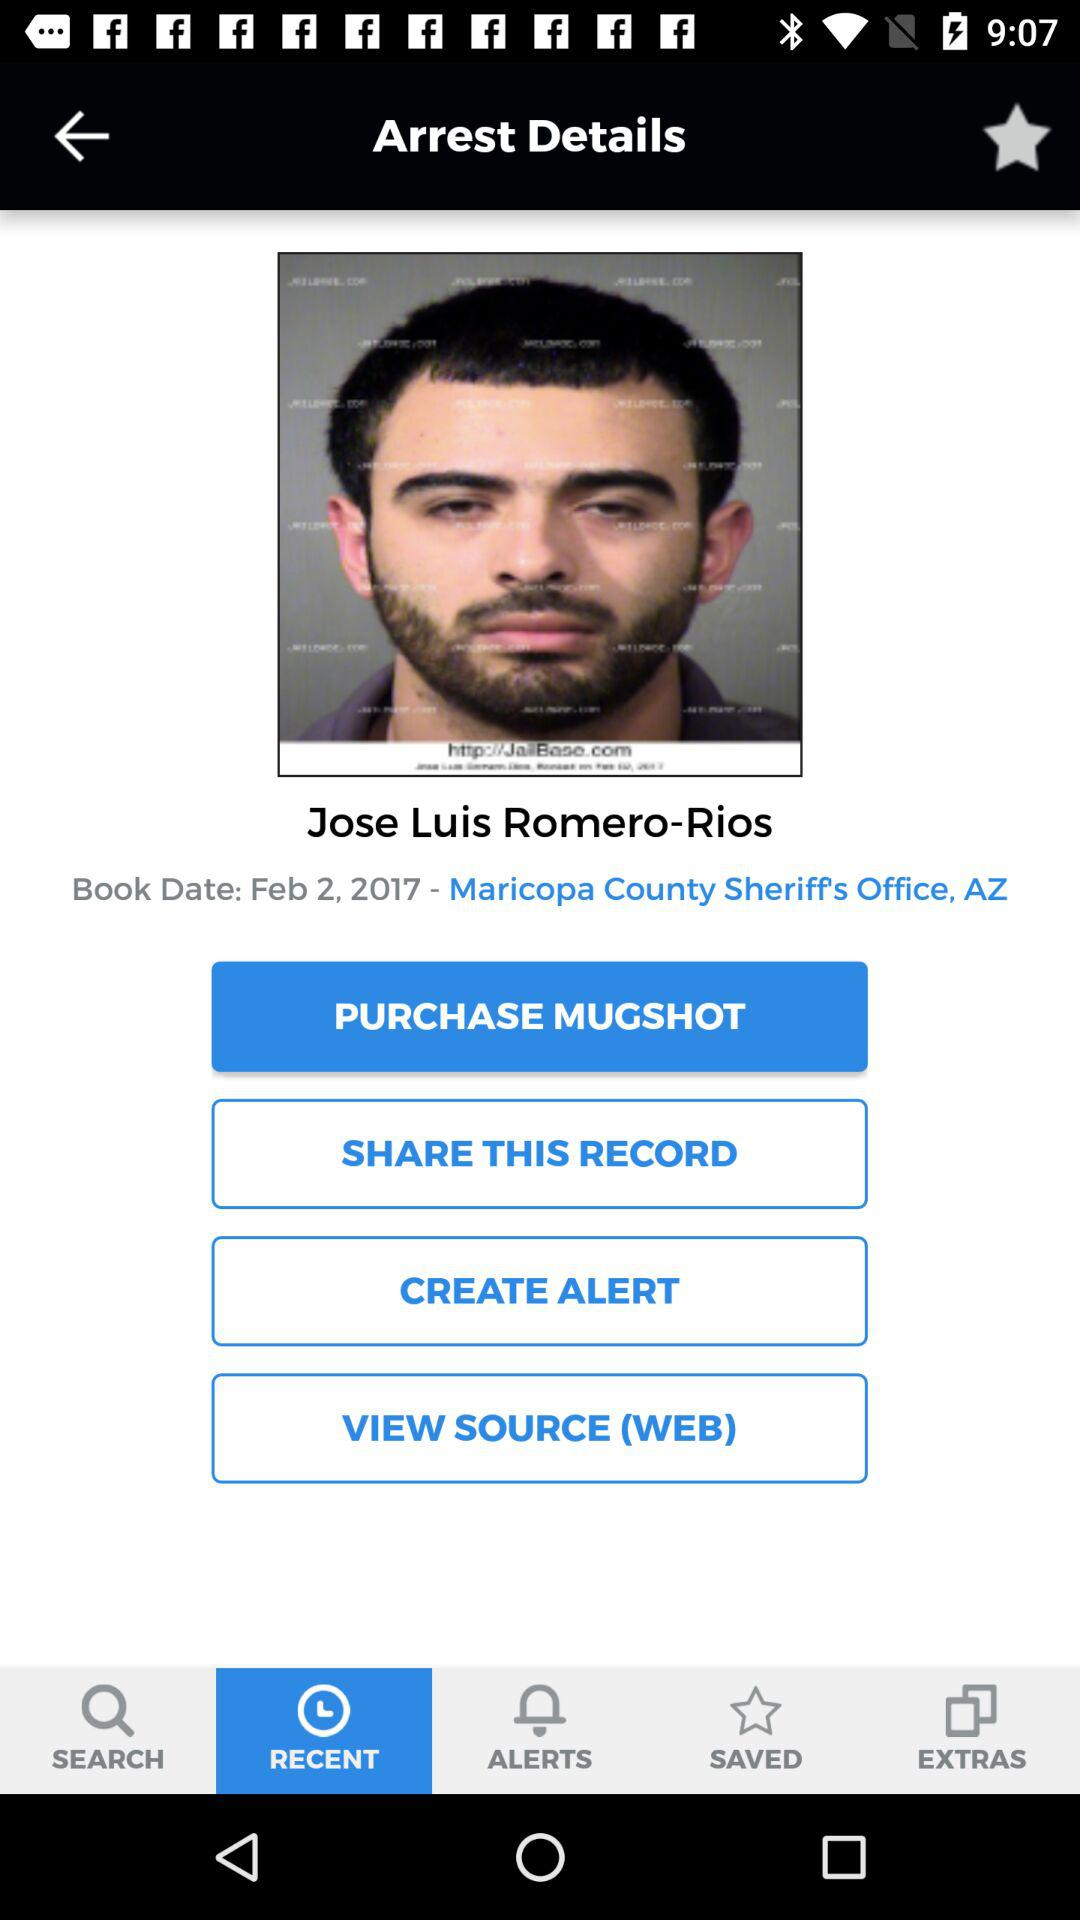What is the location? The location is the Maricopa County Sheriff's Office, AZ. 